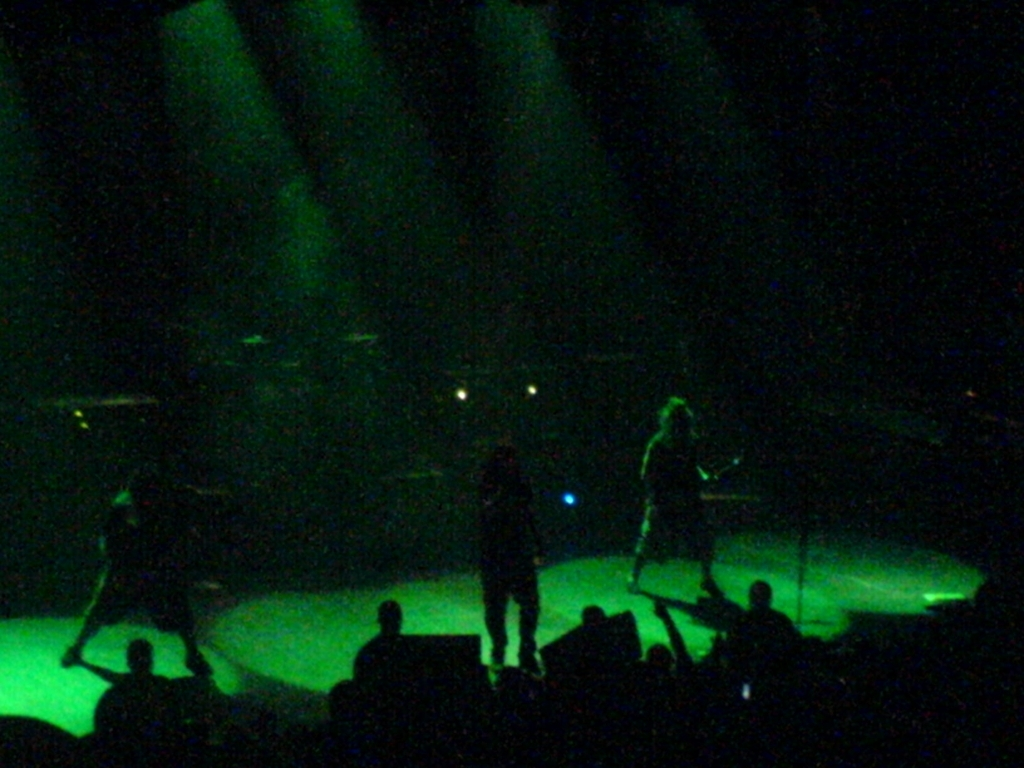Describe the lighting and why it’s important. The lighting in the image consists of sharp beams and it plays a crucial role in setting the mood and directing the audience's attention, enhancing the dramatic effect of the performance. 